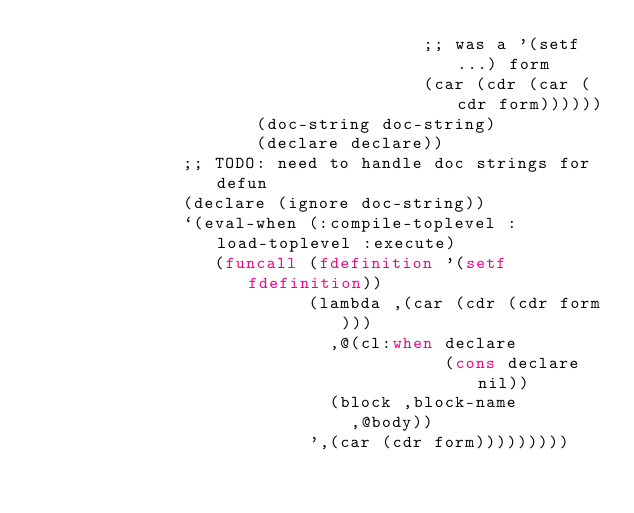Convert code to text. <code><loc_0><loc_0><loc_500><loc_500><_Lisp_>                                     ;; was a '(setf ...) form
                                     (car (cdr (car (cdr form))))))
                     (doc-string doc-string)
                     (declare declare))
              ;; TODO: need to handle doc strings for defun
              (declare (ignore doc-string))
              `(eval-when (:compile-toplevel :load-toplevel :execute)
                 (funcall (fdefinition '(setf fdefinition))
                          (lambda ,(car (cdr (cdr form)))
                            ,@(cl:when declare
                                       (cons declare nil))
                            (block ,block-name
                              ,@body))
                          ',(car (cdr form)))))))))
</code> 